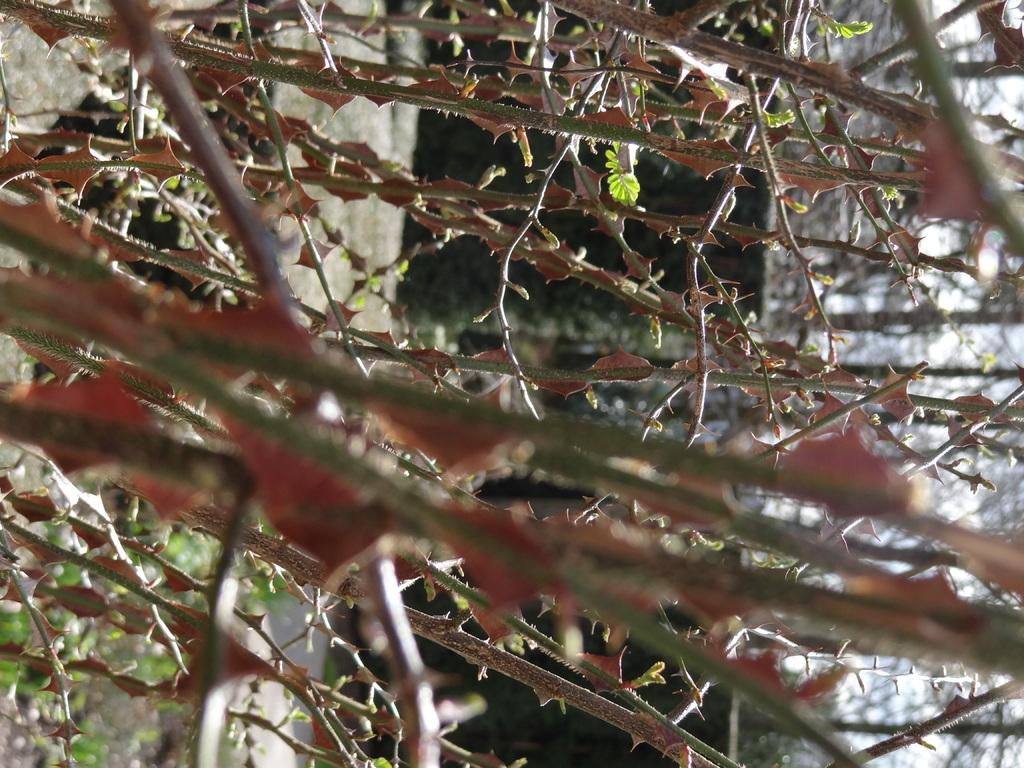What type of vegetation can be seen in the image? There are trees in the image. What feature can be observed on the stems of the trees? The stems of the trees have thorns. What type of pan is hanging from the branches of the trees in the image? There is no pan present in the image; it only features trees with thorny stems. 